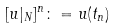<formula> <loc_0><loc_0><loc_500><loc_500>[ u | _ { N } ] ^ { n } \colon = u ( t _ { n } )</formula> 